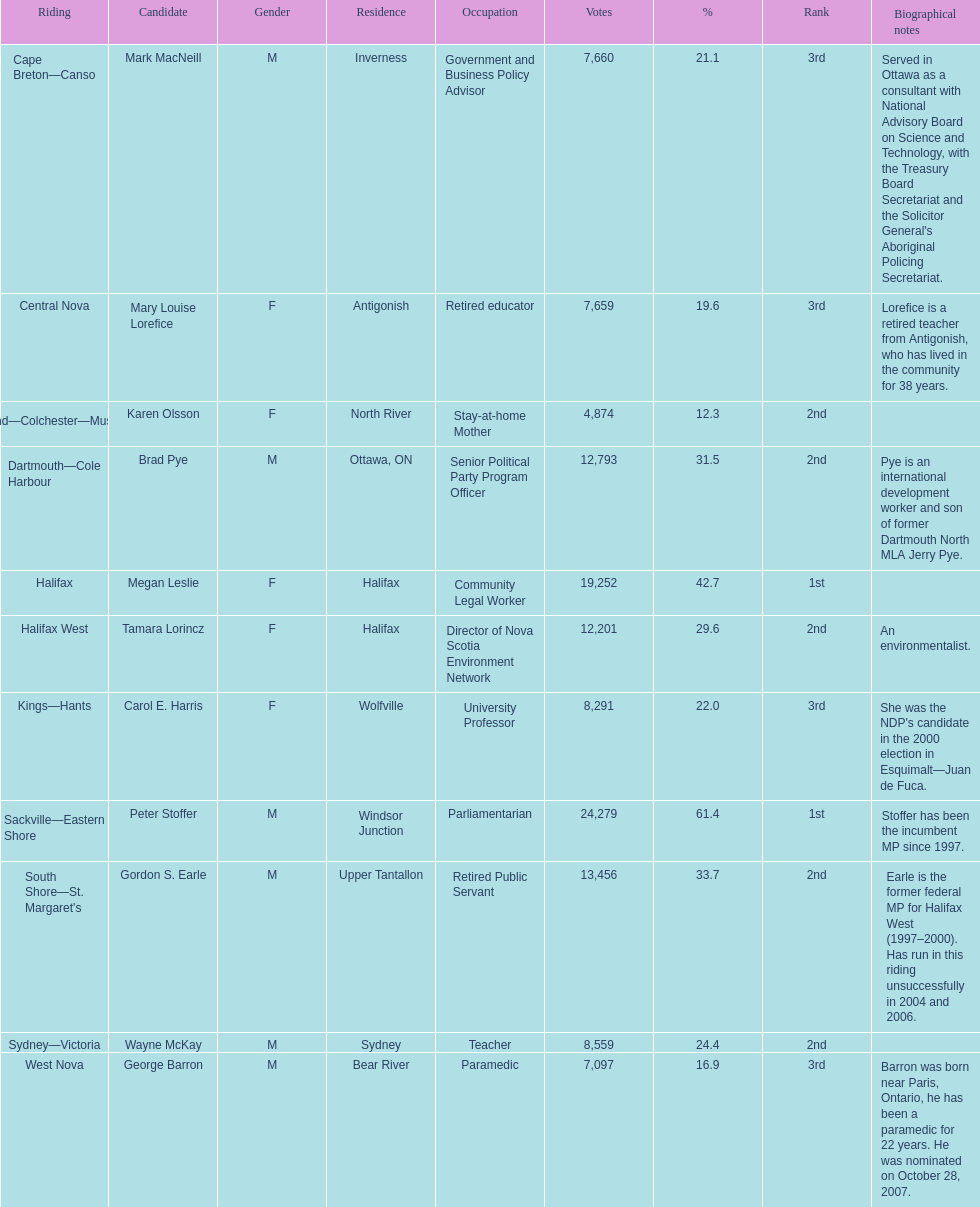How many candidates had more votes than tamara lorincz? 4. 